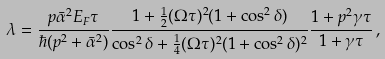Convert formula to latex. <formula><loc_0><loc_0><loc_500><loc_500>\lambda = \frac { p \bar { \alpha } ^ { 2 } E _ { F } \tau } { \hbar { ( } p ^ { 2 } + \bar { \alpha } ^ { 2 } ) } \frac { 1 + \frac { 1 } { 2 } ( \Omega \tau ) ^ { 2 } ( 1 + \cos ^ { 2 } \delta ) } { \cos ^ { 2 } \delta + \frac { 1 } { 4 } ( \Omega \tau ) ^ { 2 } ( 1 + \cos ^ { 2 } \delta ) ^ { 2 } } \frac { 1 + p ^ { 2 } \gamma \tau } { 1 + \gamma \tau } \, ,</formula> 